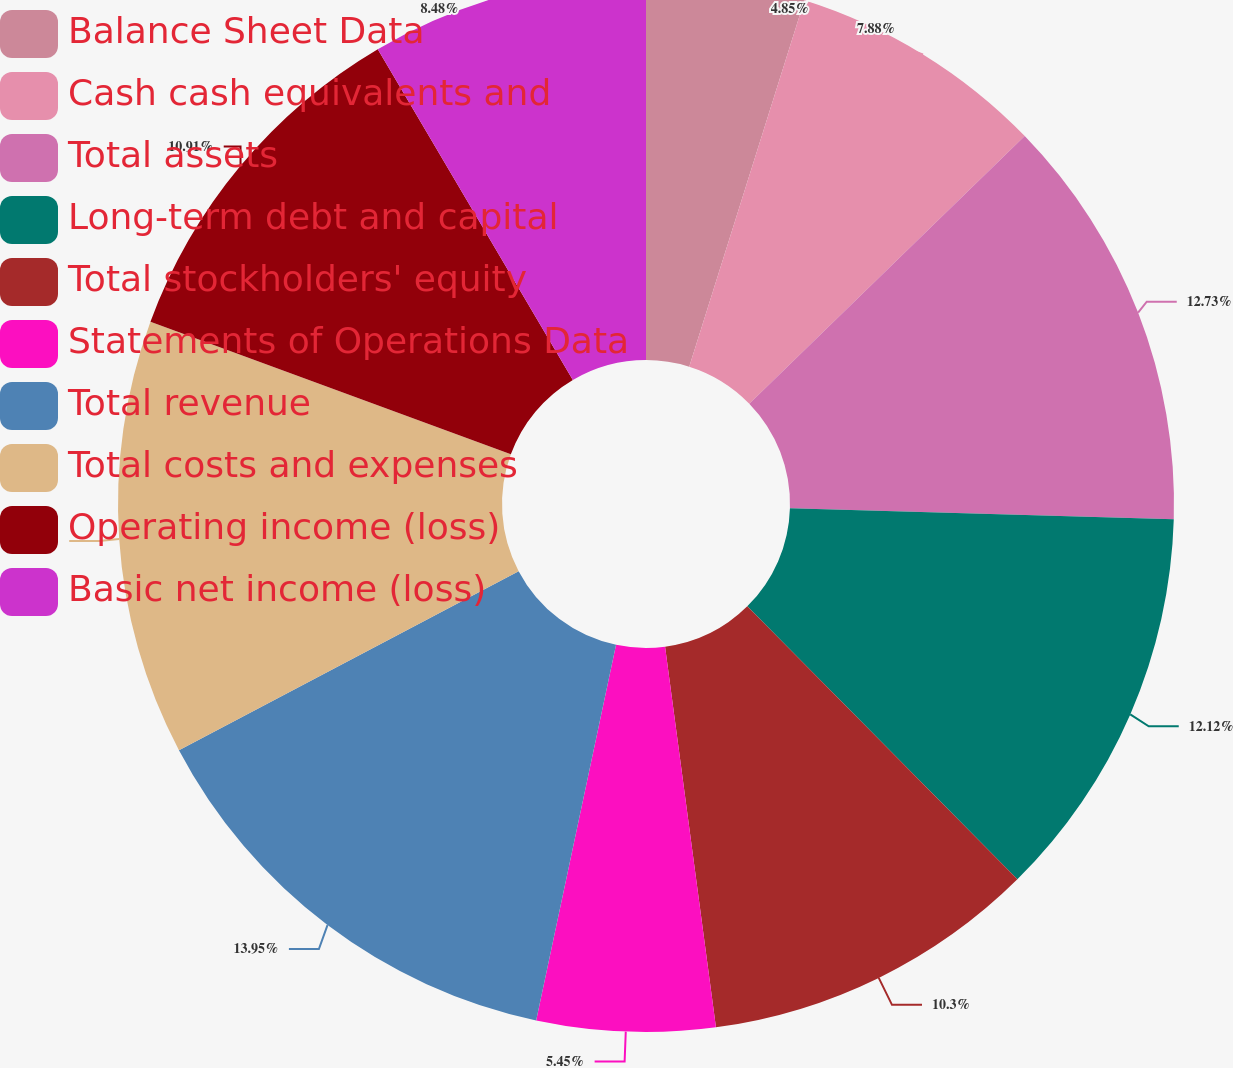Convert chart. <chart><loc_0><loc_0><loc_500><loc_500><pie_chart><fcel>Balance Sheet Data<fcel>Cash cash equivalents and<fcel>Total assets<fcel>Long-term debt and capital<fcel>Total stockholders' equity<fcel>Statements of Operations Data<fcel>Total revenue<fcel>Total costs and expenses<fcel>Operating income (loss)<fcel>Basic net income (loss)<nl><fcel>4.85%<fcel>7.88%<fcel>12.73%<fcel>12.12%<fcel>10.3%<fcel>5.45%<fcel>13.94%<fcel>13.33%<fcel>10.91%<fcel>8.48%<nl></chart> 